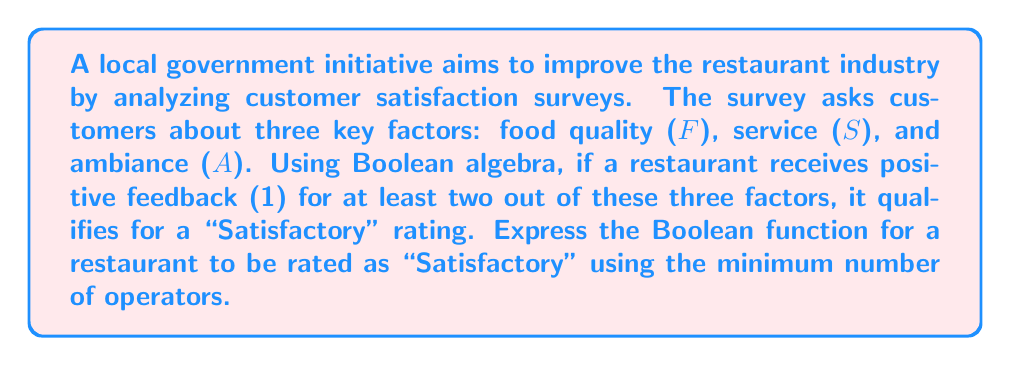Solve this math problem. Let's approach this step-by-step:

1) We need to create a Boolean function that is true (1) when at least two out of three variables (F, S, A) are true.

2) We can start by listing all the combinations where this condition is met:
   - F = 1, S = 1, A = 1
   - F = 1, S = 1, A = 0
   - F = 1, S = 0, A = 1
   - F = 0, S = 1, A = 1

3) We could express this as a sum of products:
   $$FSA + FS\bar{A} + F\bar{S}A + \bar{F}SA$$

4) However, this is not the most simplified form. We can use Boolean algebra laws to simplify further.

5) Notice that F and S appear together in the first two terms:
   $$FS(A + \bar{A}) + F\bar{S}A + \bar{F}SA$$

6) $A + \bar{A} = 1$, so this simplifies to:
   $$FS + F\bar{S}A + \bar{F}SA$$

7) We can factor out F from the first two terms:
   $$F(S + \bar{S}A) + \bar{F}SA$$

8) $S + \bar{S}A$ can be simplified to $S + A$ (this is the absorption law):
   $$F(S + A) + \bar{F}SA$$

9) Expanding this:
   $$FS + FA + \bar{F}SA$$

10) This is our final, simplified Boolean function.
Answer: $FS + FA + \bar{F}SA$ 